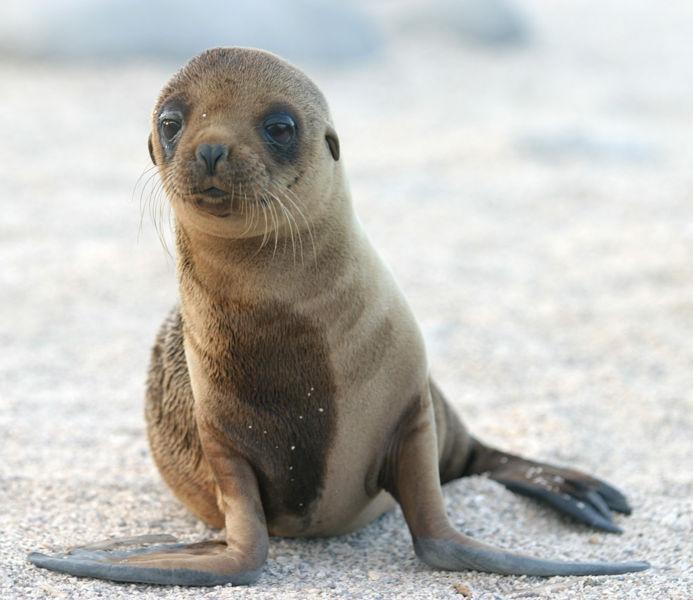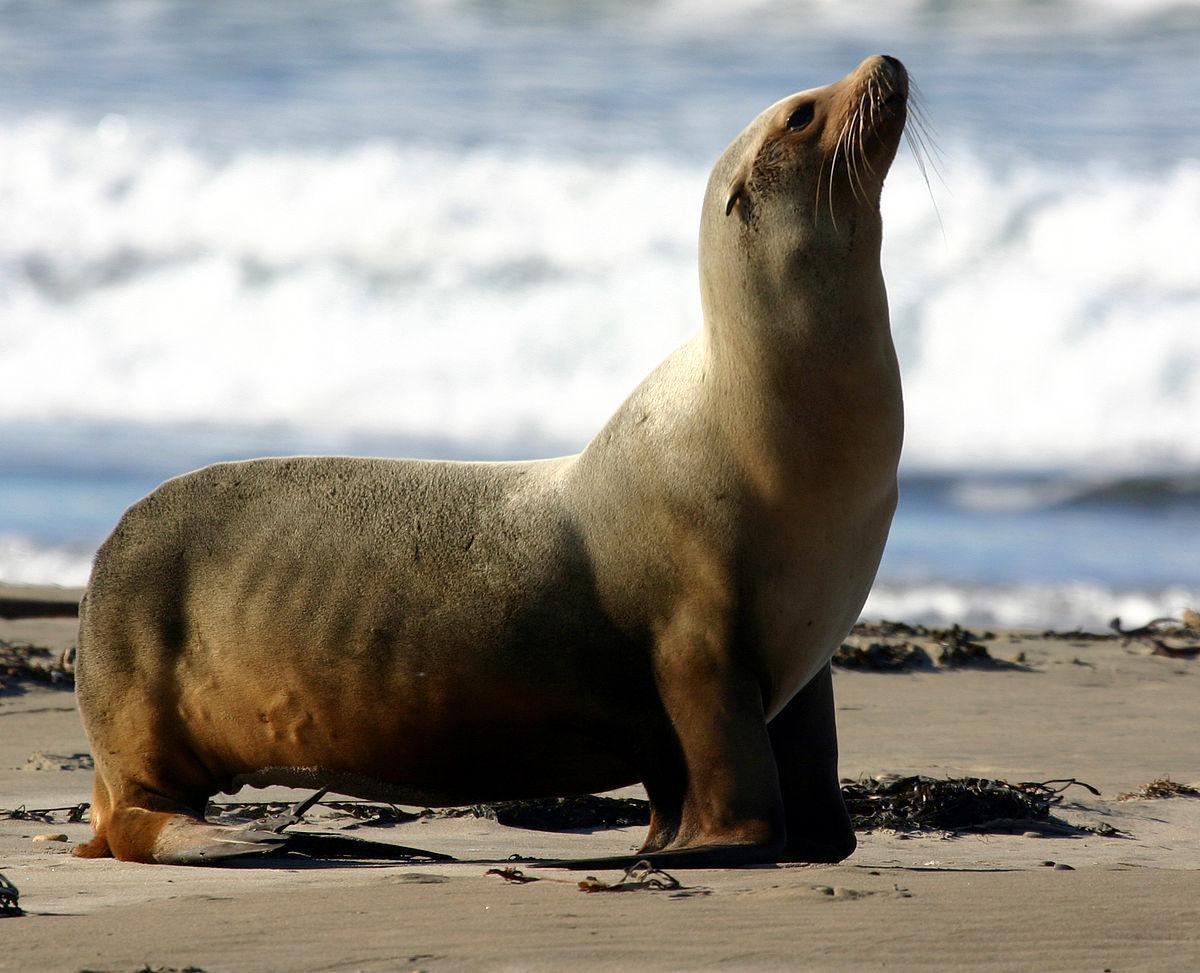The first image is the image on the left, the second image is the image on the right. Examine the images to the left and right. Is the description "In one image, there is a seal that appears to be looking directly at the camera." accurate? Answer yes or no. Yes. 